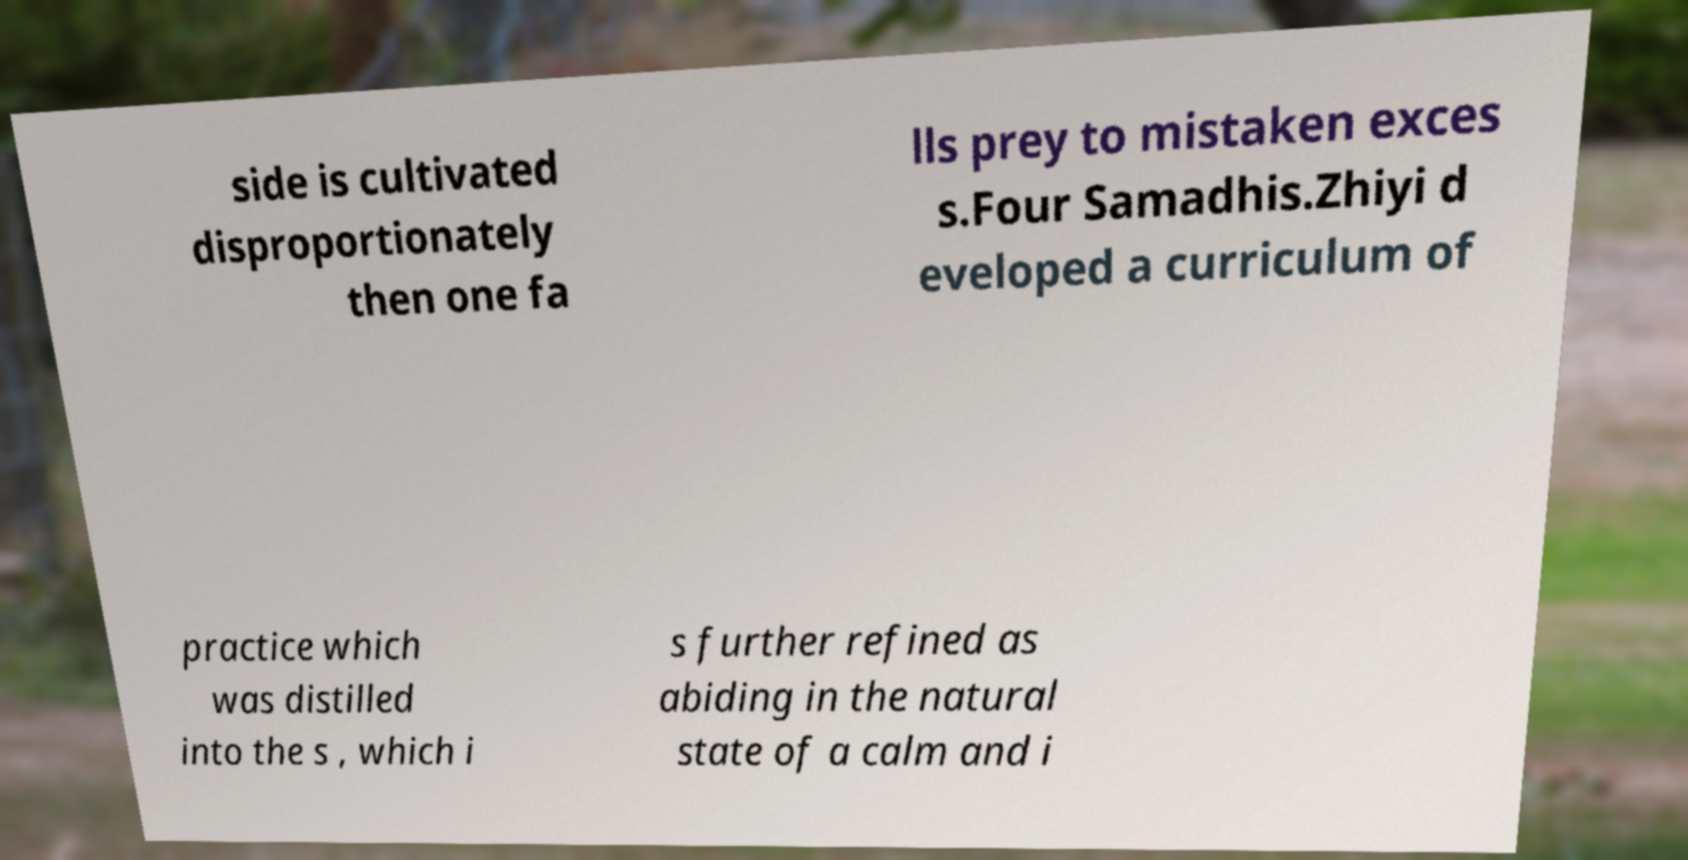Could you extract and type out the text from this image? side is cultivated disproportionately then one fa lls prey to mistaken exces s.Four Samadhis.Zhiyi d eveloped a curriculum of practice which was distilled into the s , which i s further refined as abiding in the natural state of a calm and i 